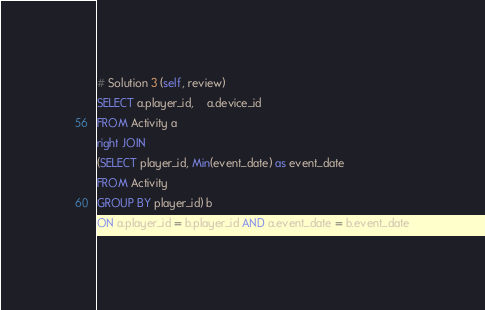<code> <loc_0><loc_0><loc_500><loc_500><_SQL_>
# Solution 3 (self, review)
SELECT a.player_id,	a.device_id
FROM Activity a
right JOIN
(SELECT player_id, Min(event_date) as event_date
FROM Activity
GROUP BY player_id) b
ON a.player_id = b.player_id AND a.event_date = b.event_date
</code> 